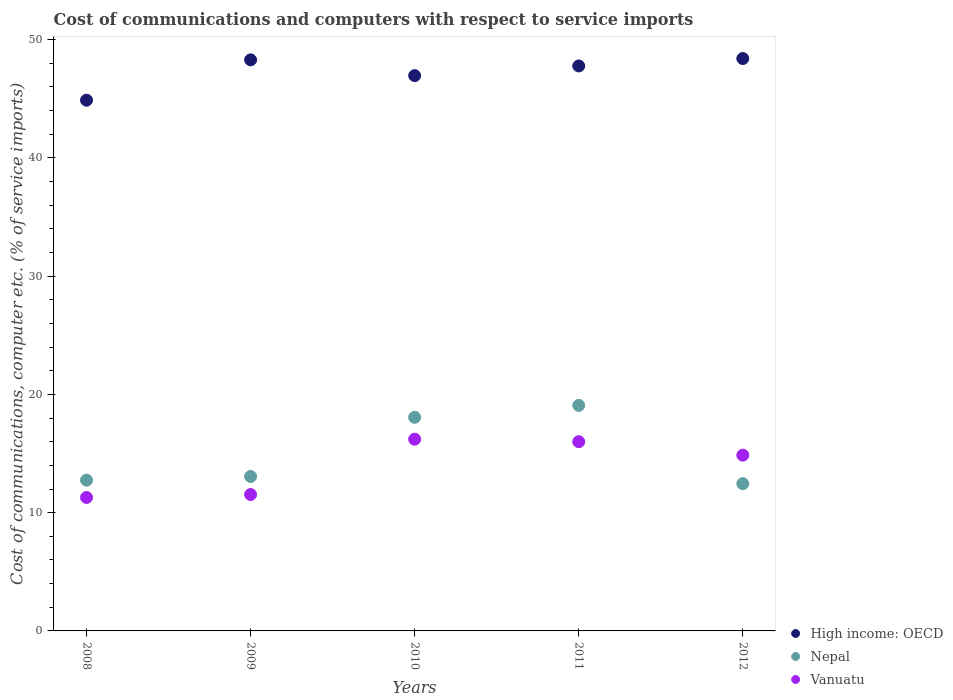What is the cost of communications and computers in High income: OECD in 2008?
Your response must be concise. 44.88. Across all years, what is the maximum cost of communications and computers in High income: OECD?
Your response must be concise. 48.41. Across all years, what is the minimum cost of communications and computers in High income: OECD?
Offer a terse response. 44.88. In which year was the cost of communications and computers in High income: OECD maximum?
Ensure brevity in your answer.  2012. What is the total cost of communications and computers in High income: OECD in the graph?
Provide a succinct answer. 236.33. What is the difference between the cost of communications and computers in Nepal in 2008 and that in 2009?
Make the answer very short. -0.31. What is the difference between the cost of communications and computers in High income: OECD in 2012 and the cost of communications and computers in Nepal in 2009?
Keep it short and to the point. 35.35. What is the average cost of communications and computers in Vanuatu per year?
Ensure brevity in your answer.  13.98. In the year 2009, what is the difference between the cost of communications and computers in Vanuatu and cost of communications and computers in Nepal?
Make the answer very short. -1.53. In how many years, is the cost of communications and computers in Vanuatu greater than 28 %?
Ensure brevity in your answer.  0. What is the ratio of the cost of communications and computers in Vanuatu in 2008 to that in 2012?
Give a very brief answer. 0.76. Is the cost of communications and computers in Vanuatu in 2008 less than that in 2012?
Offer a very short reply. Yes. Is the difference between the cost of communications and computers in Vanuatu in 2009 and 2012 greater than the difference between the cost of communications and computers in Nepal in 2009 and 2012?
Offer a very short reply. No. What is the difference between the highest and the second highest cost of communications and computers in High income: OECD?
Give a very brief answer. 0.11. What is the difference between the highest and the lowest cost of communications and computers in Vanuatu?
Your answer should be compact. 4.93. Does the cost of communications and computers in Vanuatu monotonically increase over the years?
Offer a terse response. No. How many dotlines are there?
Offer a very short reply. 3. How many years are there in the graph?
Provide a short and direct response. 5. Are the values on the major ticks of Y-axis written in scientific E-notation?
Offer a terse response. No. Where does the legend appear in the graph?
Give a very brief answer. Bottom right. How many legend labels are there?
Provide a succinct answer. 3. What is the title of the graph?
Your answer should be compact. Cost of communications and computers with respect to service imports. What is the label or title of the Y-axis?
Ensure brevity in your answer.  Cost of communications, computer etc. (% of service imports). What is the Cost of communications, computer etc. (% of service imports) of High income: OECD in 2008?
Ensure brevity in your answer.  44.88. What is the Cost of communications, computer etc. (% of service imports) in Nepal in 2008?
Your answer should be very brief. 12.75. What is the Cost of communications, computer etc. (% of service imports) of Vanuatu in 2008?
Your response must be concise. 11.29. What is the Cost of communications, computer etc. (% of service imports) of High income: OECD in 2009?
Ensure brevity in your answer.  48.29. What is the Cost of communications, computer etc. (% of service imports) of Nepal in 2009?
Your answer should be compact. 13.06. What is the Cost of communications, computer etc. (% of service imports) of Vanuatu in 2009?
Give a very brief answer. 11.53. What is the Cost of communications, computer etc. (% of service imports) of High income: OECD in 2010?
Your response must be concise. 46.96. What is the Cost of communications, computer etc. (% of service imports) of Nepal in 2010?
Make the answer very short. 18.07. What is the Cost of communications, computer etc. (% of service imports) in Vanuatu in 2010?
Your answer should be very brief. 16.21. What is the Cost of communications, computer etc. (% of service imports) of High income: OECD in 2011?
Offer a terse response. 47.78. What is the Cost of communications, computer etc. (% of service imports) in Nepal in 2011?
Your answer should be compact. 19.07. What is the Cost of communications, computer etc. (% of service imports) of Vanuatu in 2011?
Ensure brevity in your answer.  16. What is the Cost of communications, computer etc. (% of service imports) of High income: OECD in 2012?
Your answer should be very brief. 48.41. What is the Cost of communications, computer etc. (% of service imports) of Nepal in 2012?
Provide a short and direct response. 12.45. What is the Cost of communications, computer etc. (% of service imports) of Vanuatu in 2012?
Provide a short and direct response. 14.87. Across all years, what is the maximum Cost of communications, computer etc. (% of service imports) of High income: OECD?
Your response must be concise. 48.41. Across all years, what is the maximum Cost of communications, computer etc. (% of service imports) in Nepal?
Offer a terse response. 19.07. Across all years, what is the maximum Cost of communications, computer etc. (% of service imports) in Vanuatu?
Your answer should be compact. 16.21. Across all years, what is the minimum Cost of communications, computer etc. (% of service imports) in High income: OECD?
Your answer should be compact. 44.88. Across all years, what is the minimum Cost of communications, computer etc. (% of service imports) of Nepal?
Provide a succinct answer. 12.45. Across all years, what is the minimum Cost of communications, computer etc. (% of service imports) in Vanuatu?
Provide a short and direct response. 11.29. What is the total Cost of communications, computer etc. (% of service imports) of High income: OECD in the graph?
Provide a succinct answer. 236.33. What is the total Cost of communications, computer etc. (% of service imports) of Nepal in the graph?
Your response must be concise. 75.41. What is the total Cost of communications, computer etc. (% of service imports) in Vanuatu in the graph?
Provide a short and direct response. 69.9. What is the difference between the Cost of communications, computer etc. (% of service imports) of High income: OECD in 2008 and that in 2009?
Offer a very short reply. -3.41. What is the difference between the Cost of communications, computer etc. (% of service imports) of Nepal in 2008 and that in 2009?
Make the answer very short. -0.31. What is the difference between the Cost of communications, computer etc. (% of service imports) in Vanuatu in 2008 and that in 2009?
Your answer should be compact. -0.25. What is the difference between the Cost of communications, computer etc. (% of service imports) in High income: OECD in 2008 and that in 2010?
Offer a terse response. -2.08. What is the difference between the Cost of communications, computer etc. (% of service imports) in Nepal in 2008 and that in 2010?
Make the answer very short. -5.32. What is the difference between the Cost of communications, computer etc. (% of service imports) of Vanuatu in 2008 and that in 2010?
Make the answer very short. -4.93. What is the difference between the Cost of communications, computer etc. (% of service imports) in High income: OECD in 2008 and that in 2011?
Offer a terse response. -2.9. What is the difference between the Cost of communications, computer etc. (% of service imports) in Nepal in 2008 and that in 2011?
Your answer should be very brief. -6.33. What is the difference between the Cost of communications, computer etc. (% of service imports) in Vanuatu in 2008 and that in 2011?
Provide a short and direct response. -4.72. What is the difference between the Cost of communications, computer etc. (% of service imports) in High income: OECD in 2008 and that in 2012?
Offer a very short reply. -3.52. What is the difference between the Cost of communications, computer etc. (% of service imports) in Nepal in 2008 and that in 2012?
Your answer should be compact. 0.3. What is the difference between the Cost of communications, computer etc. (% of service imports) of Vanuatu in 2008 and that in 2012?
Offer a very short reply. -3.58. What is the difference between the Cost of communications, computer etc. (% of service imports) in High income: OECD in 2009 and that in 2010?
Ensure brevity in your answer.  1.33. What is the difference between the Cost of communications, computer etc. (% of service imports) of Nepal in 2009 and that in 2010?
Keep it short and to the point. -5. What is the difference between the Cost of communications, computer etc. (% of service imports) in Vanuatu in 2009 and that in 2010?
Your answer should be very brief. -4.68. What is the difference between the Cost of communications, computer etc. (% of service imports) of High income: OECD in 2009 and that in 2011?
Make the answer very short. 0.51. What is the difference between the Cost of communications, computer etc. (% of service imports) in Nepal in 2009 and that in 2011?
Keep it short and to the point. -6.01. What is the difference between the Cost of communications, computer etc. (% of service imports) of Vanuatu in 2009 and that in 2011?
Your answer should be compact. -4.47. What is the difference between the Cost of communications, computer etc. (% of service imports) in High income: OECD in 2009 and that in 2012?
Provide a succinct answer. -0.11. What is the difference between the Cost of communications, computer etc. (% of service imports) in Nepal in 2009 and that in 2012?
Offer a very short reply. 0.61. What is the difference between the Cost of communications, computer etc. (% of service imports) of Vanuatu in 2009 and that in 2012?
Ensure brevity in your answer.  -3.33. What is the difference between the Cost of communications, computer etc. (% of service imports) of High income: OECD in 2010 and that in 2011?
Offer a terse response. -0.82. What is the difference between the Cost of communications, computer etc. (% of service imports) of Nepal in 2010 and that in 2011?
Your answer should be very brief. -1.01. What is the difference between the Cost of communications, computer etc. (% of service imports) of Vanuatu in 2010 and that in 2011?
Offer a terse response. 0.21. What is the difference between the Cost of communications, computer etc. (% of service imports) of High income: OECD in 2010 and that in 2012?
Ensure brevity in your answer.  -1.45. What is the difference between the Cost of communications, computer etc. (% of service imports) in Nepal in 2010 and that in 2012?
Give a very brief answer. 5.61. What is the difference between the Cost of communications, computer etc. (% of service imports) of Vanuatu in 2010 and that in 2012?
Make the answer very short. 1.35. What is the difference between the Cost of communications, computer etc. (% of service imports) of High income: OECD in 2011 and that in 2012?
Your answer should be very brief. -0.63. What is the difference between the Cost of communications, computer etc. (% of service imports) in Nepal in 2011 and that in 2012?
Keep it short and to the point. 6.62. What is the difference between the Cost of communications, computer etc. (% of service imports) in Vanuatu in 2011 and that in 2012?
Your response must be concise. 1.14. What is the difference between the Cost of communications, computer etc. (% of service imports) in High income: OECD in 2008 and the Cost of communications, computer etc. (% of service imports) in Nepal in 2009?
Offer a terse response. 31.82. What is the difference between the Cost of communications, computer etc. (% of service imports) in High income: OECD in 2008 and the Cost of communications, computer etc. (% of service imports) in Vanuatu in 2009?
Your answer should be very brief. 33.35. What is the difference between the Cost of communications, computer etc. (% of service imports) in Nepal in 2008 and the Cost of communications, computer etc. (% of service imports) in Vanuatu in 2009?
Provide a short and direct response. 1.21. What is the difference between the Cost of communications, computer etc. (% of service imports) of High income: OECD in 2008 and the Cost of communications, computer etc. (% of service imports) of Nepal in 2010?
Give a very brief answer. 26.82. What is the difference between the Cost of communications, computer etc. (% of service imports) in High income: OECD in 2008 and the Cost of communications, computer etc. (% of service imports) in Vanuatu in 2010?
Provide a short and direct response. 28.67. What is the difference between the Cost of communications, computer etc. (% of service imports) of Nepal in 2008 and the Cost of communications, computer etc. (% of service imports) of Vanuatu in 2010?
Give a very brief answer. -3.47. What is the difference between the Cost of communications, computer etc. (% of service imports) of High income: OECD in 2008 and the Cost of communications, computer etc. (% of service imports) of Nepal in 2011?
Offer a very short reply. 25.81. What is the difference between the Cost of communications, computer etc. (% of service imports) of High income: OECD in 2008 and the Cost of communications, computer etc. (% of service imports) of Vanuatu in 2011?
Ensure brevity in your answer.  28.88. What is the difference between the Cost of communications, computer etc. (% of service imports) in Nepal in 2008 and the Cost of communications, computer etc. (% of service imports) in Vanuatu in 2011?
Your response must be concise. -3.25. What is the difference between the Cost of communications, computer etc. (% of service imports) of High income: OECD in 2008 and the Cost of communications, computer etc. (% of service imports) of Nepal in 2012?
Ensure brevity in your answer.  32.43. What is the difference between the Cost of communications, computer etc. (% of service imports) of High income: OECD in 2008 and the Cost of communications, computer etc. (% of service imports) of Vanuatu in 2012?
Offer a very short reply. 30.02. What is the difference between the Cost of communications, computer etc. (% of service imports) of Nepal in 2008 and the Cost of communications, computer etc. (% of service imports) of Vanuatu in 2012?
Give a very brief answer. -2.12. What is the difference between the Cost of communications, computer etc. (% of service imports) of High income: OECD in 2009 and the Cost of communications, computer etc. (% of service imports) of Nepal in 2010?
Give a very brief answer. 30.23. What is the difference between the Cost of communications, computer etc. (% of service imports) of High income: OECD in 2009 and the Cost of communications, computer etc. (% of service imports) of Vanuatu in 2010?
Provide a short and direct response. 32.08. What is the difference between the Cost of communications, computer etc. (% of service imports) in Nepal in 2009 and the Cost of communications, computer etc. (% of service imports) in Vanuatu in 2010?
Offer a terse response. -3.15. What is the difference between the Cost of communications, computer etc. (% of service imports) of High income: OECD in 2009 and the Cost of communications, computer etc. (% of service imports) of Nepal in 2011?
Your answer should be compact. 29.22. What is the difference between the Cost of communications, computer etc. (% of service imports) in High income: OECD in 2009 and the Cost of communications, computer etc. (% of service imports) in Vanuatu in 2011?
Provide a succinct answer. 32.29. What is the difference between the Cost of communications, computer etc. (% of service imports) of Nepal in 2009 and the Cost of communications, computer etc. (% of service imports) of Vanuatu in 2011?
Make the answer very short. -2.94. What is the difference between the Cost of communications, computer etc. (% of service imports) in High income: OECD in 2009 and the Cost of communications, computer etc. (% of service imports) in Nepal in 2012?
Ensure brevity in your answer.  35.84. What is the difference between the Cost of communications, computer etc. (% of service imports) of High income: OECD in 2009 and the Cost of communications, computer etc. (% of service imports) of Vanuatu in 2012?
Provide a short and direct response. 33.43. What is the difference between the Cost of communications, computer etc. (% of service imports) of Nepal in 2009 and the Cost of communications, computer etc. (% of service imports) of Vanuatu in 2012?
Offer a very short reply. -1.8. What is the difference between the Cost of communications, computer etc. (% of service imports) in High income: OECD in 2010 and the Cost of communications, computer etc. (% of service imports) in Nepal in 2011?
Keep it short and to the point. 27.89. What is the difference between the Cost of communications, computer etc. (% of service imports) in High income: OECD in 2010 and the Cost of communications, computer etc. (% of service imports) in Vanuatu in 2011?
Give a very brief answer. 30.96. What is the difference between the Cost of communications, computer etc. (% of service imports) of Nepal in 2010 and the Cost of communications, computer etc. (% of service imports) of Vanuatu in 2011?
Give a very brief answer. 2.06. What is the difference between the Cost of communications, computer etc. (% of service imports) of High income: OECD in 2010 and the Cost of communications, computer etc. (% of service imports) of Nepal in 2012?
Your answer should be very brief. 34.51. What is the difference between the Cost of communications, computer etc. (% of service imports) in High income: OECD in 2010 and the Cost of communications, computer etc. (% of service imports) in Vanuatu in 2012?
Offer a very short reply. 32.1. What is the difference between the Cost of communications, computer etc. (% of service imports) of Nepal in 2010 and the Cost of communications, computer etc. (% of service imports) of Vanuatu in 2012?
Offer a terse response. 3.2. What is the difference between the Cost of communications, computer etc. (% of service imports) of High income: OECD in 2011 and the Cost of communications, computer etc. (% of service imports) of Nepal in 2012?
Make the answer very short. 35.33. What is the difference between the Cost of communications, computer etc. (% of service imports) of High income: OECD in 2011 and the Cost of communications, computer etc. (% of service imports) of Vanuatu in 2012?
Make the answer very short. 32.91. What is the difference between the Cost of communications, computer etc. (% of service imports) in Nepal in 2011 and the Cost of communications, computer etc. (% of service imports) in Vanuatu in 2012?
Make the answer very short. 4.21. What is the average Cost of communications, computer etc. (% of service imports) in High income: OECD per year?
Provide a short and direct response. 47.27. What is the average Cost of communications, computer etc. (% of service imports) of Nepal per year?
Keep it short and to the point. 15.08. What is the average Cost of communications, computer etc. (% of service imports) of Vanuatu per year?
Keep it short and to the point. 13.98. In the year 2008, what is the difference between the Cost of communications, computer etc. (% of service imports) of High income: OECD and Cost of communications, computer etc. (% of service imports) of Nepal?
Your response must be concise. 32.13. In the year 2008, what is the difference between the Cost of communications, computer etc. (% of service imports) in High income: OECD and Cost of communications, computer etc. (% of service imports) in Vanuatu?
Provide a succinct answer. 33.6. In the year 2008, what is the difference between the Cost of communications, computer etc. (% of service imports) of Nepal and Cost of communications, computer etc. (% of service imports) of Vanuatu?
Your response must be concise. 1.46. In the year 2009, what is the difference between the Cost of communications, computer etc. (% of service imports) of High income: OECD and Cost of communications, computer etc. (% of service imports) of Nepal?
Give a very brief answer. 35.23. In the year 2009, what is the difference between the Cost of communications, computer etc. (% of service imports) in High income: OECD and Cost of communications, computer etc. (% of service imports) in Vanuatu?
Keep it short and to the point. 36.76. In the year 2009, what is the difference between the Cost of communications, computer etc. (% of service imports) of Nepal and Cost of communications, computer etc. (% of service imports) of Vanuatu?
Offer a terse response. 1.53. In the year 2010, what is the difference between the Cost of communications, computer etc. (% of service imports) of High income: OECD and Cost of communications, computer etc. (% of service imports) of Nepal?
Provide a short and direct response. 28.9. In the year 2010, what is the difference between the Cost of communications, computer etc. (% of service imports) of High income: OECD and Cost of communications, computer etc. (% of service imports) of Vanuatu?
Offer a terse response. 30.75. In the year 2010, what is the difference between the Cost of communications, computer etc. (% of service imports) in Nepal and Cost of communications, computer etc. (% of service imports) in Vanuatu?
Make the answer very short. 1.85. In the year 2011, what is the difference between the Cost of communications, computer etc. (% of service imports) in High income: OECD and Cost of communications, computer etc. (% of service imports) in Nepal?
Give a very brief answer. 28.71. In the year 2011, what is the difference between the Cost of communications, computer etc. (% of service imports) of High income: OECD and Cost of communications, computer etc. (% of service imports) of Vanuatu?
Give a very brief answer. 31.78. In the year 2011, what is the difference between the Cost of communications, computer etc. (% of service imports) in Nepal and Cost of communications, computer etc. (% of service imports) in Vanuatu?
Offer a terse response. 3.07. In the year 2012, what is the difference between the Cost of communications, computer etc. (% of service imports) in High income: OECD and Cost of communications, computer etc. (% of service imports) in Nepal?
Keep it short and to the point. 35.95. In the year 2012, what is the difference between the Cost of communications, computer etc. (% of service imports) of High income: OECD and Cost of communications, computer etc. (% of service imports) of Vanuatu?
Your response must be concise. 33.54. In the year 2012, what is the difference between the Cost of communications, computer etc. (% of service imports) in Nepal and Cost of communications, computer etc. (% of service imports) in Vanuatu?
Make the answer very short. -2.41. What is the ratio of the Cost of communications, computer etc. (% of service imports) in High income: OECD in 2008 to that in 2009?
Offer a terse response. 0.93. What is the ratio of the Cost of communications, computer etc. (% of service imports) in Nepal in 2008 to that in 2009?
Your answer should be compact. 0.98. What is the ratio of the Cost of communications, computer etc. (% of service imports) of Vanuatu in 2008 to that in 2009?
Keep it short and to the point. 0.98. What is the ratio of the Cost of communications, computer etc. (% of service imports) in High income: OECD in 2008 to that in 2010?
Your response must be concise. 0.96. What is the ratio of the Cost of communications, computer etc. (% of service imports) in Nepal in 2008 to that in 2010?
Make the answer very short. 0.71. What is the ratio of the Cost of communications, computer etc. (% of service imports) in Vanuatu in 2008 to that in 2010?
Offer a terse response. 0.7. What is the ratio of the Cost of communications, computer etc. (% of service imports) in High income: OECD in 2008 to that in 2011?
Offer a very short reply. 0.94. What is the ratio of the Cost of communications, computer etc. (% of service imports) in Nepal in 2008 to that in 2011?
Your answer should be very brief. 0.67. What is the ratio of the Cost of communications, computer etc. (% of service imports) in Vanuatu in 2008 to that in 2011?
Your response must be concise. 0.71. What is the ratio of the Cost of communications, computer etc. (% of service imports) in High income: OECD in 2008 to that in 2012?
Give a very brief answer. 0.93. What is the ratio of the Cost of communications, computer etc. (% of service imports) in Nepal in 2008 to that in 2012?
Your response must be concise. 1.02. What is the ratio of the Cost of communications, computer etc. (% of service imports) in Vanuatu in 2008 to that in 2012?
Make the answer very short. 0.76. What is the ratio of the Cost of communications, computer etc. (% of service imports) of High income: OECD in 2009 to that in 2010?
Offer a terse response. 1.03. What is the ratio of the Cost of communications, computer etc. (% of service imports) in Nepal in 2009 to that in 2010?
Keep it short and to the point. 0.72. What is the ratio of the Cost of communications, computer etc. (% of service imports) of Vanuatu in 2009 to that in 2010?
Provide a succinct answer. 0.71. What is the ratio of the Cost of communications, computer etc. (% of service imports) of High income: OECD in 2009 to that in 2011?
Make the answer very short. 1.01. What is the ratio of the Cost of communications, computer etc. (% of service imports) in Nepal in 2009 to that in 2011?
Ensure brevity in your answer.  0.68. What is the ratio of the Cost of communications, computer etc. (% of service imports) of Vanuatu in 2009 to that in 2011?
Your answer should be very brief. 0.72. What is the ratio of the Cost of communications, computer etc. (% of service imports) in Nepal in 2009 to that in 2012?
Offer a very short reply. 1.05. What is the ratio of the Cost of communications, computer etc. (% of service imports) of Vanuatu in 2009 to that in 2012?
Offer a terse response. 0.78. What is the ratio of the Cost of communications, computer etc. (% of service imports) in High income: OECD in 2010 to that in 2011?
Ensure brevity in your answer.  0.98. What is the ratio of the Cost of communications, computer etc. (% of service imports) of Nepal in 2010 to that in 2011?
Make the answer very short. 0.95. What is the ratio of the Cost of communications, computer etc. (% of service imports) in Vanuatu in 2010 to that in 2011?
Make the answer very short. 1.01. What is the ratio of the Cost of communications, computer etc. (% of service imports) of High income: OECD in 2010 to that in 2012?
Offer a very short reply. 0.97. What is the ratio of the Cost of communications, computer etc. (% of service imports) of Nepal in 2010 to that in 2012?
Ensure brevity in your answer.  1.45. What is the ratio of the Cost of communications, computer etc. (% of service imports) of Vanuatu in 2010 to that in 2012?
Keep it short and to the point. 1.09. What is the ratio of the Cost of communications, computer etc. (% of service imports) of Nepal in 2011 to that in 2012?
Keep it short and to the point. 1.53. What is the ratio of the Cost of communications, computer etc. (% of service imports) of Vanuatu in 2011 to that in 2012?
Your answer should be very brief. 1.08. What is the difference between the highest and the second highest Cost of communications, computer etc. (% of service imports) of High income: OECD?
Offer a terse response. 0.11. What is the difference between the highest and the second highest Cost of communications, computer etc. (% of service imports) in Nepal?
Keep it short and to the point. 1.01. What is the difference between the highest and the second highest Cost of communications, computer etc. (% of service imports) of Vanuatu?
Provide a short and direct response. 0.21. What is the difference between the highest and the lowest Cost of communications, computer etc. (% of service imports) of High income: OECD?
Provide a succinct answer. 3.52. What is the difference between the highest and the lowest Cost of communications, computer etc. (% of service imports) in Nepal?
Give a very brief answer. 6.62. What is the difference between the highest and the lowest Cost of communications, computer etc. (% of service imports) in Vanuatu?
Your answer should be compact. 4.93. 